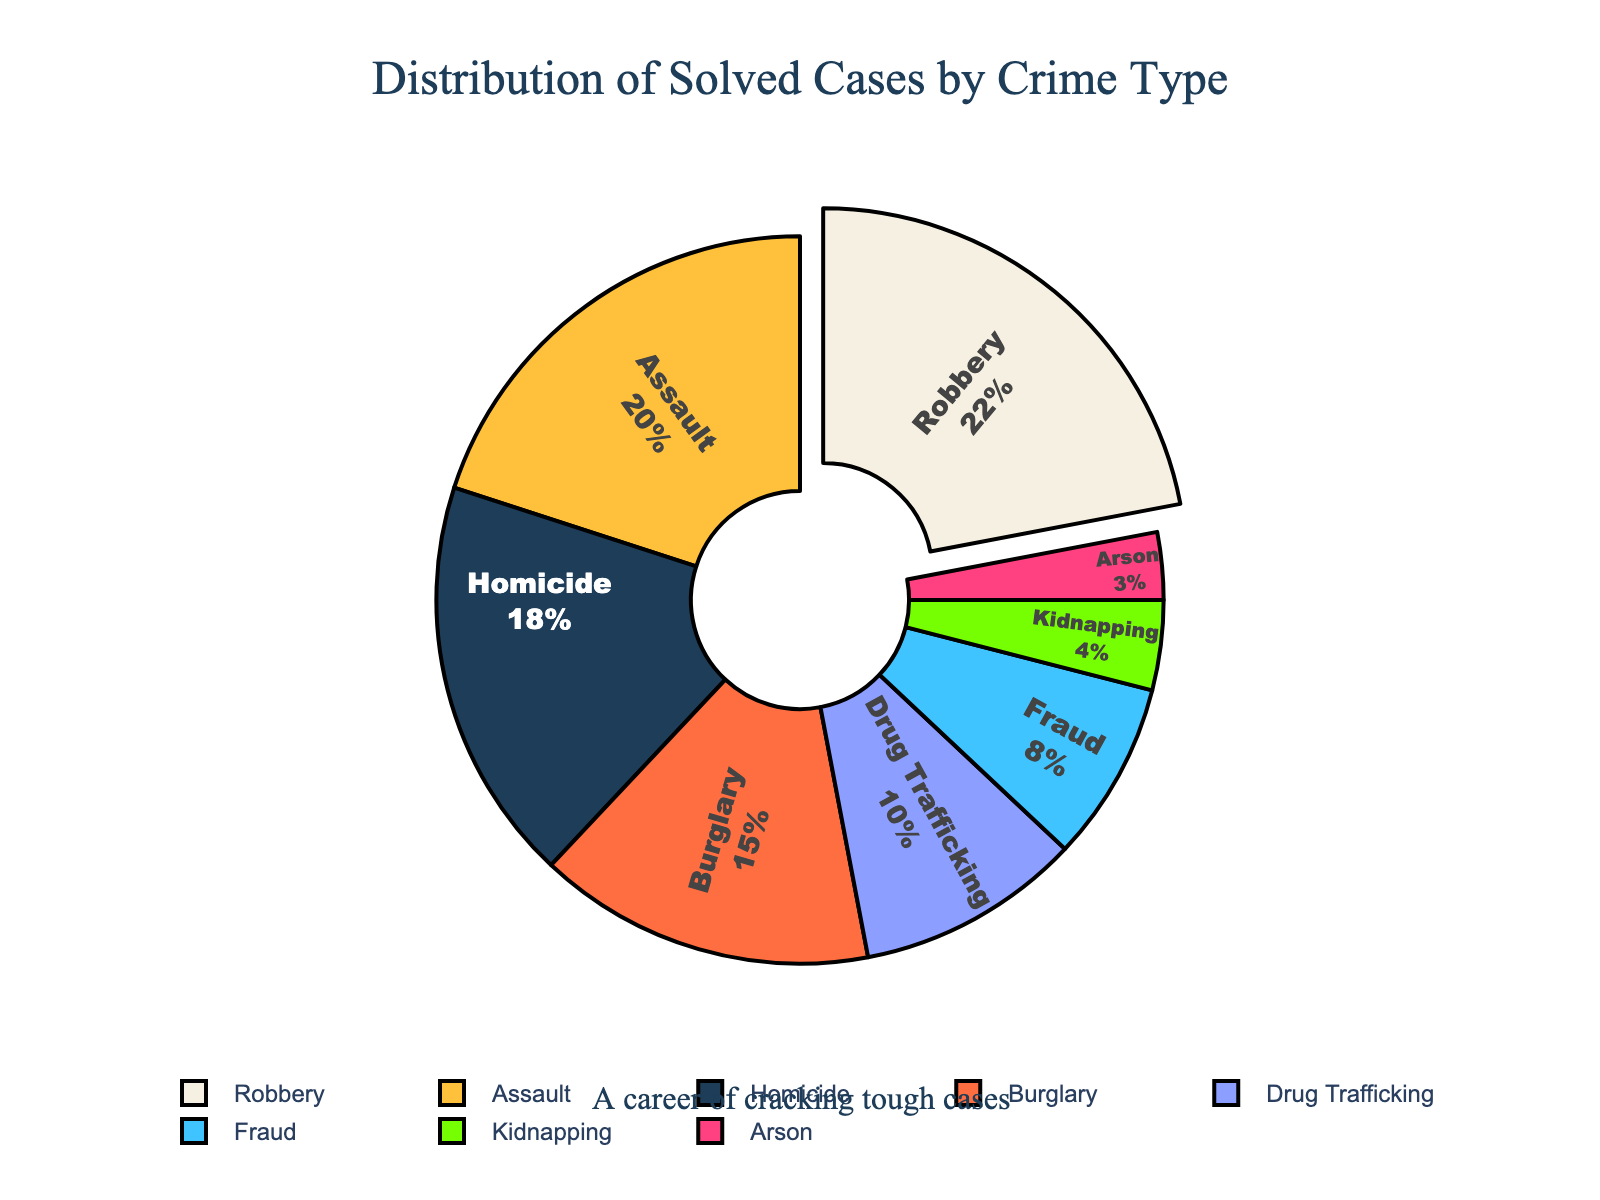What percentage of the solved cases were for Homicide? The pie chart segment for Homicide indicates the percentage value inside the segment.
Answer: 18% Which crime type had the highest percentage of solved cases? The segment with the highest percentage is highlighted and possibly pulled out from the pie chart. This indicates it is the largest portion.
Answer: Robbery How do the percentages for Burglary and Assault combined compare to the percentage for Robbery? Add the percentages for Burglary (15%) and Assault (20%) and compare the sum (35%) to that of Robbery (22%).
Answer: 35% vs. 22% Are there more solved cases for Drug Trafficking or Fraud? Compare the individual segment percentages for Drug Trafficking (10%) and Fraud (8%).
Answer: Drug Trafficking What is the difference in percentage between Homicide and Kidnapping? Subtract the percentage of Kidnapping (4%) from the percentage of Homicide (18%).
Answer: 14% Which crime type has the smallest percentage of solved cases? Look for the smallest segment in the pie chart, which corresponds to the smallest percentage value.
Answer: Arson Is the percentage of solved cases for Assault greater than the sum of Arson and Kidnapping percentages? Compare the percentage for Assault (20%) to the sum of Arson (3%) and Kidnapping (4%), which is 7%.
Answer: Yes How do the combined percentages of solved cases for Robbery and Fraud compare to the percentage for Homicide? Add the percentages for Robbery (22%) and Fraud (8%) to get 30%, then compare this to Homicide (18%).
Answer: 30% vs. 18% Which two crime types combined have a percentage close to that of the total solved cases for Robbery? Look for two crime types whose percentages sum up to about 22%. Burglary (15%) and Kidnapping (4%) combined with Arson (3%) adds up to 22%.
Answer: Burglary and Kidnapping (or Arson) What color represents Drug Trafficking? Identify the section for Drug Trafficking and note its color from the segment of the pie chart.
Answer: Blue 